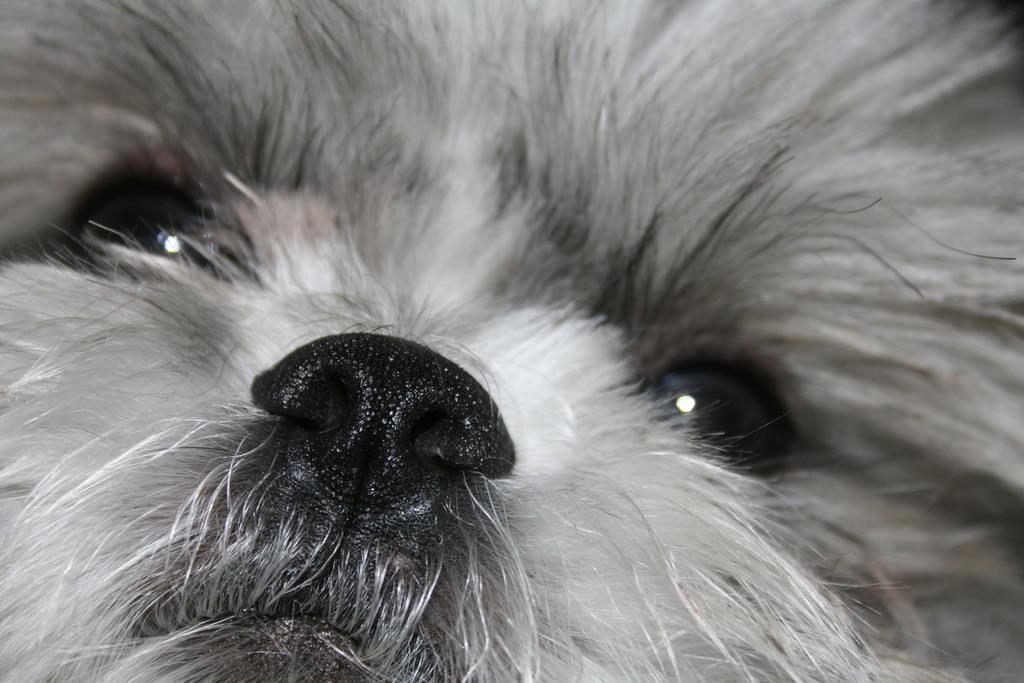In one or two sentences, can you explain what this image depicts? In this image I can see the dog which is in black and white color. 